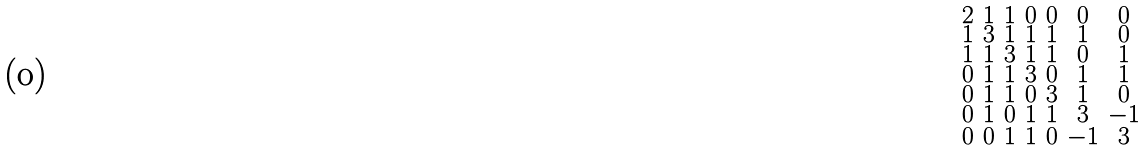Convert formula to latex. <formula><loc_0><loc_0><loc_500><loc_500>\begin{smallmatrix} 2 & 1 & 1 & 0 & 0 & 0 & 0 \\ 1 & 3 & 1 & 1 & 1 & 1 & 0 \\ 1 & 1 & 3 & 1 & 1 & 0 & 1 \\ 0 & 1 & 1 & 3 & 0 & 1 & 1 \\ 0 & 1 & 1 & 0 & 3 & 1 & 0 \\ 0 & 1 & 0 & 1 & 1 & 3 & - 1 \\ 0 & 0 & 1 & 1 & 0 & - 1 & 3 \end{smallmatrix}</formula> 